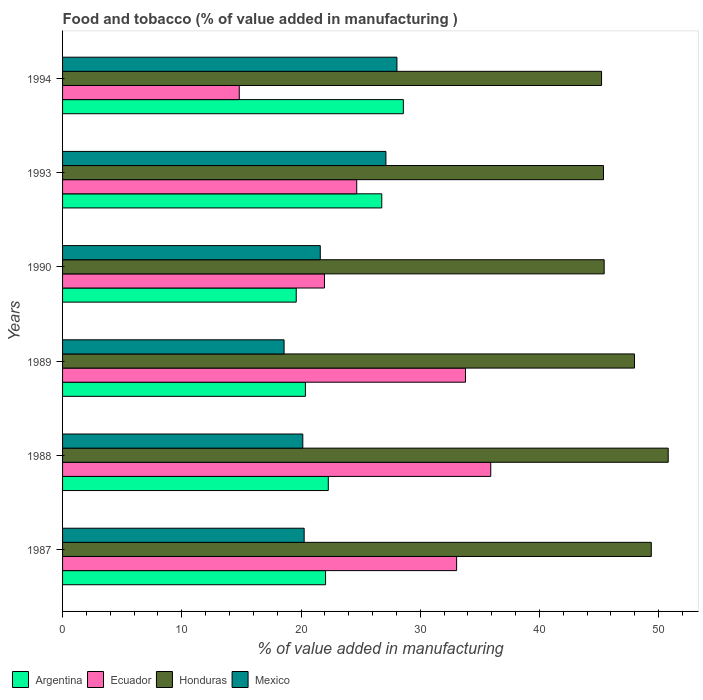How many different coloured bars are there?
Your response must be concise. 4. How many bars are there on the 6th tick from the top?
Make the answer very short. 4. How many bars are there on the 5th tick from the bottom?
Offer a very short reply. 4. What is the value added in manufacturing food and tobacco in Honduras in 1990?
Make the answer very short. 45.43. Across all years, what is the maximum value added in manufacturing food and tobacco in Mexico?
Provide a short and direct response. 28.05. Across all years, what is the minimum value added in manufacturing food and tobacco in Argentina?
Give a very brief answer. 19.6. What is the total value added in manufacturing food and tobacco in Mexico in the graph?
Offer a terse response. 135.79. What is the difference between the value added in manufacturing food and tobacco in Ecuador in 1987 and that in 1989?
Your response must be concise. -0.74. What is the difference between the value added in manufacturing food and tobacco in Honduras in 1990 and the value added in manufacturing food and tobacco in Ecuador in 1987?
Your answer should be compact. 12.38. What is the average value added in manufacturing food and tobacco in Honduras per year?
Provide a succinct answer. 47.36. In the year 1990, what is the difference between the value added in manufacturing food and tobacco in Argentina and value added in manufacturing food and tobacco in Honduras?
Offer a very short reply. -25.83. What is the ratio of the value added in manufacturing food and tobacco in Honduras in 1993 to that in 1994?
Keep it short and to the point. 1. Is the value added in manufacturing food and tobacco in Ecuador in 1987 less than that in 1994?
Provide a short and direct response. No. What is the difference between the highest and the second highest value added in manufacturing food and tobacco in Mexico?
Provide a short and direct response. 0.92. What is the difference between the highest and the lowest value added in manufacturing food and tobacco in Honduras?
Keep it short and to the point. 5.59. In how many years, is the value added in manufacturing food and tobacco in Ecuador greater than the average value added in manufacturing food and tobacco in Ecuador taken over all years?
Your answer should be very brief. 3. Is the sum of the value added in manufacturing food and tobacco in Ecuador in 1987 and 1994 greater than the maximum value added in manufacturing food and tobacco in Argentina across all years?
Make the answer very short. Yes. What does the 4th bar from the bottom in 1993 represents?
Ensure brevity in your answer.  Mexico. Is it the case that in every year, the sum of the value added in manufacturing food and tobacco in Honduras and value added in manufacturing food and tobacco in Ecuador is greater than the value added in manufacturing food and tobacco in Argentina?
Provide a succinct answer. Yes. Are all the bars in the graph horizontal?
Keep it short and to the point. Yes. How many years are there in the graph?
Make the answer very short. 6. Are the values on the major ticks of X-axis written in scientific E-notation?
Offer a very short reply. No. Does the graph contain any zero values?
Your answer should be compact. No. Does the graph contain grids?
Your answer should be compact. No. Where does the legend appear in the graph?
Your answer should be compact. Bottom left. How many legend labels are there?
Keep it short and to the point. 4. How are the legend labels stacked?
Provide a succinct answer. Horizontal. What is the title of the graph?
Make the answer very short. Food and tobacco (% of value added in manufacturing ). What is the label or title of the X-axis?
Give a very brief answer. % of value added in manufacturing. What is the % of value added in manufacturing in Argentina in 1987?
Offer a terse response. 22.06. What is the % of value added in manufacturing in Ecuador in 1987?
Provide a short and direct response. 33.05. What is the % of value added in manufacturing of Honduras in 1987?
Offer a terse response. 49.38. What is the % of value added in manufacturing in Mexico in 1987?
Make the answer very short. 20.26. What is the % of value added in manufacturing in Argentina in 1988?
Your answer should be very brief. 22.29. What is the % of value added in manufacturing of Ecuador in 1988?
Your answer should be compact. 35.92. What is the % of value added in manufacturing in Honduras in 1988?
Your answer should be compact. 50.8. What is the % of value added in manufacturing of Mexico in 1988?
Keep it short and to the point. 20.15. What is the % of value added in manufacturing of Argentina in 1989?
Your answer should be very brief. 20.37. What is the % of value added in manufacturing of Ecuador in 1989?
Your answer should be very brief. 33.8. What is the % of value added in manufacturing in Honduras in 1989?
Make the answer very short. 47.97. What is the % of value added in manufacturing of Mexico in 1989?
Provide a succinct answer. 18.58. What is the % of value added in manufacturing in Argentina in 1990?
Ensure brevity in your answer.  19.6. What is the % of value added in manufacturing of Ecuador in 1990?
Your answer should be very brief. 21.97. What is the % of value added in manufacturing in Honduras in 1990?
Keep it short and to the point. 45.43. What is the % of value added in manufacturing of Mexico in 1990?
Your answer should be compact. 21.62. What is the % of value added in manufacturing in Argentina in 1993?
Make the answer very short. 26.77. What is the % of value added in manufacturing of Ecuador in 1993?
Your answer should be compact. 24.68. What is the % of value added in manufacturing of Honduras in 1993?
Your answer should be very brief. 45.37. What is the % of value added in manufacturing of Mexico in 1993?
Offer a terse response. 27.12. What is the % of value added in manufacturing of Argentina in 1994?
Make the answer very short. 28.58. What is the % of value added in manufacturing of Ecuador in 1994?
Make the answer very short. 14.82. What is the % of value added in manufacturing of Honduras in 1994?
Your answer should be compact. 45.21. What is the % of value added in manufacturing in Mexico in 1994?
Keep it short and to the point. 28.05. Across all years, what is the maximum % of value added in manufacturing of Argentina?
Give a very brief answer. 28.58. Across all years, what is the maximum % of value added in manufacturing in Ecuador?
Give a very brief answer. 35.92. Across all years, what is the maximum % of value added in manufacturing of Honduras?
Your answer should be compact. 50.8. Across all years, what is the maximum % of value added in manufacturing of Mexico?
Offer a very short reply. 28.05. Across all years, what is the minimum % of value added in manufacturing of Argentina?
Your response must be concise. 19.6. Across all years, what is the minimum % of value added in manufacturing in Ecuador?
Offer a terse response. 14.82. Across all years, what is the minimum % of value added in manufacturing of Honduras?
Your response must be concise. 45.21. Across all years, what is the minimum % of value added in manufacturing of Mexico?
Ensure brevity in your answer.  18.58. What is the total % of value added in manufacturing in Argentina in the graph?
Your response must be concise. 139.68. What is the total % of value added in manufacturing in Ecuador in the graph?
Your answer should be very brief. 164.23. What is the total % of value added in manufacturing in Honduras in the graph?
Your answer should be compact. 284.17. What is the total % of value added in manufacturing of Mexico in the graph?
Your response must be concise. 135.79. What is the difference between the % of value added in manufacturing in Argentina in 1987 and that in 1988?
Your answer should be very brief. -0.23. What is the difference between the % of value added in manufacturing in Ecuador in 1987 and that in 1988?
Your response must be concise. -2.86. What is the difference between the % of value added in manufacturing in Honduras in 1987 and that in 1988?
Make the answer very short. -1.42. What is the difference between the % of value added in manufacturing of Mexico in 1987 and that in 1988?
Your response must be concise. 0.11. What is the difference between the % of value added in manufacturing of Argentina in 1987 and that in 1989?
Your answer should be compact. 1.69. What is the difference between the % of value added in manufacturing in Ecuador in 1987 and that in 1989?
Your response must be concise. -0.74. What is the difference between the % of value added in manufacturing in Honduras in 1987 and that in 1989?
Keep it short and to the point. 1.41. What is the difference between the % of value added in manufacturing in Mexico in 1987 and that in 1989?
Keep it short and to the point. 1.68. What is the difference between the % of value added in manufacturing in Argentina in 1987 and that in 1990?
Make the answer very short. 2.46. What is the difference between the % of value added in manufacturing in Ecuador in 1987 and that in 1990?
Your response must be concise. 11.08. What is the difference between the % of value added in manufacturing of Honduras in 1987 and that in 1990?
Make the answer very short. 3.95. What is the difference between the % of value added in manufacturing of Mexico in 1987 and that in 1990?
Provide a succinct answer. -1.35. What is the difference between the % of value added in manufacturing of Argentina in 1987 and that in 1993?
Provide a short and direct response. -4.71. What is the difference between the % of value added in manufacturing in Ecuador in 1987 and that in 1993?
Give a very brief answer. 8.38. What is the difference between the % of value added in manufacturing of Honduras in 1987 and that in 1993?
Your response must be concise. 4.01. What is the difference between the % of value added in manufacturing of Mexico in 1987 and that in 1993?
Your answer should be very brief. -6.86. What is the difference between the % of value added in manufacturing of Argentina in 1987 and that in 1994?
Offer a very short reply. -6.53. What is the difference between the % of value added in manufacturing of Ecuador in 1987 and that in 1994?
Offer a very short reply. 18.23. What is the difference between the % of value added in manufacturing in Honduras in 1987 and that in 1994?
Offer a terse response. 4.17. What is the difference between the % of value added in manufacturing in Mexico in 1987 and that in 1994?
Your answer should be compact. -7.78. What is the difference between the % of value added in manufacturing in Argentina in 1988 and that in 1989?
Make the answer very short. 1.92. What is the difference between the % of value added in manufacturing in Ecuador in 1988 and that in 1989?
Your answer should be very brief. 2.12. What is the difference between the % of value added in manufacturing of Honduras in 1988 and that in 1989?
Give a very brief answer. 2.83. What is the difference between the % of value added in manufacturing of Mexico in 1988 and that in 1989?
Offer a terse response. 1.57. What is the difference between the % of value added in manufacturing in Argentina in 1988 and that in 1990?
Make the answer very short. 2.69. What is the difference between the % of value added in manufacturing of Ecuador in 1988 and that in 1990?
Your answer should be compact. 13.95. What is the difference between the % of value added in manufacturing in Honduras in 1988 and that in 1990?
Keep it short and to the point. 5.37. What is the difference between the % of value added in manufacturing in Mexico in 1988 and that in 1990?
Offer a very short reply. -1.47. What is the difference between the % of value added in manufacturing in Argentina in 1988 and that in 1993?
Ensure brevity in your answer.  -4.48. What is the difference between the % of value added in manufacturing of Ecuador in 1988 and that in 1993?
Your response must be concise. 11.24. What is the difference between the % of value added in manufacturing of Honduras in 1988 and that in 1993?
Keep it short and to the point. 5.43. What is the difference between the % of value added in manufacturing of Mexico in 1988 and that in 1993?
Offer a terse response. -6.97. What is the difference between the % of value added in manufacturing of Argentina in 1988 and that in 1994?
Ensure brevity in your answer.  -6.29. What is the difference between the % of value added in manufacturing in Ecuador in 1988 and that in 1994?
Your answer should be compact. 21.1. What is the difference between the % of value added in manufacturing in Honduras in 1988 and that in 1994?
Your response must be concise. 5.59. What is the difference between the % of value added in manufacturing of Mexico in 1988 and that in 1994?
Give a very brief answer. -7.9. What is the difference between the % of value added in manufacturing in Argentina in 1989 and that in 1990?
Your answer should be very brief. 0.77. What is the difference between the % of value added in manufacturing in Ecuador in 1989 and that in 1990?
Ensure brevity in your answer.  11.83. What is the difference between the % of value added in manufacturing in Honduras in 1989 and that in 1990?
Your response must be concise. 2.54. What is the difference between the % of value added in manufacturing of Mexico in 1989 and that in 1990?
Offer a very short reply. -3.04. What is the difference between the % of value added in manufacturing of Argentina in 1989 and that in 1993?
Your answer should be compact. -6.4. What is the difference between the % of value added in manufacturing of Ecuador in 1989 and that in 1993?
Offer a very short reply. 9.12. What is the difference between the % of value added in manufacturing of Honduras in 1989 and that in 1993?
Your answer should be compact. 2.6. What is the difference between the % of value added in manufacturing of Mexico in 1989 and that in 1993?
Provide a short and direct response. -8.54. What is the difference between the % of value added in manufacturing in Argentina in 1989 and that in 1994?
Make the answer very short. -8.21. What is the difference between the % of value added in manufacturing of Ecuador in 1989 and that in 1994?
Give a very brief answer. 18.98. What is the difference between the % of value added in manufacturing in Honduras in 1989 and that in 1994?
Provide a short and direct response. 2.76. What is the difference between the % of value added in manufacturing of Mexico in 1989 and that in 1994?
Make the answer very short. -9.47. What is the difference between the % of value added in manufacturing in Argentina in 1990 and that in 1993?
Your answer should be compact. -7.17. What is the difference between the % of value added in manufacturing of Ecuador in 1990 and that in 1993?
Provide a short and direct response. -2.71. What is the difference between the % of value added in manufacturing of Honduras in 1990 and that in 1993?
Make the answer very short. 0.06. What is the difference between the % of value added in manufacturing in Mexico in 1990 and that in 1993?
Your answer should be very brief. -5.51. What is the difference between the % of value added in manufacturing of Argentina in 1990 and that in 1994?
Offer a very short reply. -8.98. What is the difference between the % of value added in manufacturing of Ecuador in 1990 and that in 1994?
Your response must be concise. 7.15. What is the difference between the % of value added in manufacturing in Honduras in 1990 and that in 1994?
Ensure brevity in your answer.  0.22. What is the difference between the % of value added in manufacturing of Mexico in 1990 and that in 1994?
Your response must be concise. -6.43. What is the difference between the % of value added in manufacturing of Argentina in 1993 and that in 1994?
Offer a very short reply. -1.81. What is the difference between the % of value added in manufacturing in Ecuador in 1993 and that in 1994?
Offer a very short reply. 9.85. What is the difference between the % of value added in manufacturing in Honduras in 1993 and that in 1994?
Ensure brevity in your answer.  0.16. What is the difference between the % of value added in manufacturing of Mexico in 1993 and that in 1994?
Give a very brief answer. -0.92. What is the difference between the % of value added in manufacturing of Argentina in 1987 and the % of value added in manufacturing of Ecuador in 1988?
Give a very brief answer. -13.86. What is the difference between the % of value added in manufacturing of Argentina in 1987 and the % of value added in manufacturing of Honduras in 1988?
Keep it short and to the point. -28.74. What is the difference between the % of value added in manufacturing of Argentina in 1987 and the % of value added in manufacturing of Mexico in 1988?
Give a very brief answer. 1.91. What is the difference between the % of value added in manufacturing in Ecuador in 1987 and the % of value added in manufacturing in Honduras in 1988?
Your answer should be compact. -17.75. What is the difference between the % of value added in manufacturing of Ecuador in 1987 and the % of value added in manufacturing of Mexico in 1988?
Provide a succinct answer. 12.9. What is the difference between the % of value added in manufacturing in Honduras in 1987 and the % of value added in manufacturing in Mexico in 1988?
Your answer should be compact. 29.23. What is the difference between the % of value added in manufacturing of Argentina in 1987 and the % of value added in manufacturing of Ecuador in 1989?
Your response must be concise. -11.74. What is the difference between the % of value added in manufacturing in Argentina in 1987 and the % of value added in manufacturing in Honduras in 1989?
Offer a terse response. -25.91. What is the difference between the % of value added in manufacturing of Argentina in 1987 and the % of value added in manufacturing of Mexico in 1989?
Give a very brief answer. 3.48. What is the difference between the % of value added in manufacturing of Ecuador in 1987 and the % of value added in manufacturing of Honduras in 1989?
Keep it short and to the point. -14.92. What is the difference between the % of value added in manufacturing of Ecuador in 1987 and the % of value added in manufacturing of Mexico in 1989?
Provide a succinct answer. 14.47. What is the difference between the % of value added in manufacturing in Honduras in 1987 and the % of value added in manufacturing in Mexico in 1989?
Your answer should be compact. 30.8. What is the difference between the % of value added in manufacturing in Argentina in 1987 and the % of value added in manufacturing in Ecuador in 1990?
Give a very brief answer. 0.09. What is the difference between the % of value added in manufacturing in Argentina in 1987 and the % of value added in manufacturing in Honduras in 1990?
Provide a short and direct response. -23.37. What is the difference between the % of value added in manufacturing of Argentina in 1987 and the % of value added in manufacturing of Mexico in 1990?
Keep it short and to the point. 0.44. What is the difference between the % of value added in manufacturing in Ecuador in 1987 and the % of value added in manufacturing in Honduras in 1990?
Provide a short and direct response. -12.38. What is the difference between the % of value added in manufacturing in Ecuador in 1987 and the % of value added in manufacturing in Mexico in 1990?
Your answer should be very brief. 11.44. What is the difference between the % of value added in manufacturing of Honduras in 1987 and the % of value added in manufacturing of Mexico in 1990?
Offer a terse response. 27.77. What is the difference between the % of value added in manufacturing in Argentina in 1987 and the % of value added in manufacturing in Ecuador in 1993?
Your answer should be very brief. -2.62. What is the difference between the % of value added in manufacturing in Argentina in 1987 and the % of value added in manufacturing in Honduras in 1993?
Make the answer very short. -23.31. What is the difference between the % of value added in manufacturing of Argentina in 1987 and the % of value added in manufacturing of Mexico in 1993?
Give a very brief answer. -5.06. What is the difference between the % of value added in manufacturing in Ecuador in 1987 and the % of value added in manufacturing in Honduras in 1993?
Your response must be concise. -12.32. What is the difference between the % of value added in manufacturing in Ecuador in 1987 and the % of value added in manufacturing in Mexico in 1993?
Give a very brief answer. 5.93. What is the difference between the % of value added in manufacturing of Honduras in 1987 and the % of value added in manufacturing of Mexico in 1993?
Your response must be concise. 22.26. What is the difference between the % of value added in manufacturing in Argentina in 1987 and the % of value added in manufacturing in Ecuador in 1994?
Ensure brevity in your answer.  7.24. What is the difference between the % of value added in manufacturing of Argentina in 1987 and the % of value added in manufacturing of Honduras in 1994?
Ensure brevity in your answer.  -23.15. What is the difference between the % of value added in manufacturing of Argentina in 1987 and the % of value added in manufacturing of Mexico in 1994?
Offer a terse response. -5.99. What is the difference between the % of value added in manufacturing in Ecuador in 1987 and the % of value added in manufacturing in Honduras in 1994?
Ensure brevity in your answer.  -12.16. What is the difference between the % of value added in manufacturing of Ecuador in 1987 and the % of value added in manufacturing of Mexico in 1994?
Make the answer very short. 5.01. What is the difference between the % of value added in manufacturing in Honduras in 1987 and the % of value added in manufacturing in Mexico in 1994?
Your answer should be compact. 21.34. What is the difference between the % of value added in manufacturing in Argentina in 1988 and the % of value added in manufacturing in Ecuador in 1989?
Your answer should be very brief. -11.51. What is the difference between the % of value added in manufacturing of Argentina in 1988 and the % of value added in manufacturing of Honduras in 1989?
Give a very brief answer. -25.68. What is the difference between the % of value added in manufacturing of Argentina in 1988 and the % of value added in manufacturing of Mexico in 1989?
Ensure brevity in your answer.  3.71. What is the difference between the % of value added in manufacturing of Ecuador in 1988 and the % of value added in manufacturing of Honduras in 1989?
Provide a succinct answer. -12.05. What is the difference between the % of value added in manufacturing of Ecuador in 1988 and the % of value added in manufacturing of Mexico in 1989?
Keep it short and to the point. 17.34. What is the difference between the % of value added in manufacturing of Honduras in 1988 and the % of value added in manufacturing of Mexico in 1989?
Your answer should be very brief. 32.22. What is the difference between the % of value added in manufacturing in Argentina in 1988 and the % of value added in manufacturing in Ecuador in 1990?
Offer a very short reply. 0.32. What is the difference between the % of value added in manufacturing of Argentina in 1988 and the % of value added in manufacturing of Honduras in 1990?
Your response must be concise. -23.14. What is the difference between the % of value added in manufacturing in Argentina in 1988 and the % of value added in manufacturing in Mexico in 1990?
Offer a terse response. 0.67. What is the difference between the % of value added in manufacturing of Ecuador in 1988 and the % of value added in manufacturing of Honduras in 1990?
Your answer should be compact. -9.51. What is the difference between the % of value added in manufacturing of Ecuador in 1988 and the % of value added in manufacturing of Mexico in 1990?
Provide a short and direct response. 14.3. What is the difference between the % of value added in manufacturing of Honduras in 1988 and the % of value added in manufacturing of Mexico in 1990?
Provide a succinct answer. 29.18. What is the difference between the % of value added in manufacturing in Argentina in 1988 and the % of value added in manufacturing in Ecuador in 1993?
Your response must be concise. -2.39. What is the difference between the % of value added in manufacturing in Argentina in 1988 and the % of value added in manufacturing in Honduras in 1993?
Your response must be concise. -23.08. What is the difference between the % of value added in manufacturing in Argentina in 1988 and the % of value added in manufacturing in Mexico in 1993?
Offer a terse response. -4.83. What is the difference between the % of value added in manufacturing in Ecuador in 1988 and the % of value added in manufacturing in Honduras in 1993?
Provide a succinct answer. -9.46. What is the difference between the % of value added in manufacturing in Ecuador in 1988 and the % of value added in manufacturing in Mexico in 1993?
Your answer should be very brief. 8.79. What is the difference between the % of value added in manufacturing in Honduras in 1988 and the % of value added in manufacturing in Mexico in 1993?
Your response must be concise. 23.68. What is the difference between the % of value added in manufacturing of Argentina in 1988 and the % of value added in manufacturing of Ecuador in 1994?
Give a very brief answer. 7.47. What is the difference between the % of value added in manufacturing of Argentina in 1988 and the % of value added in manufacturing of Honduras in 1994?
Your answer should be compact. -22.92. What is the difference between the % of value added in manufacturing of Argentina in 1988 and the % of value added in manufacturing of Mexico in 1994?
Your response must be concise. -5.76. What is the difference between the % of value added in manufacturing of Ecuador in 1988 and the % of value added in manufacturing of Honduras in 1994?
Offer a very short reply. -9.29. What is the difference between the % of value added in manufacturing in Ecuador in 1988 and the % of value added in manufacturing in Mexico in 1994?
Offer a very short reply. 7.87. What is the difference between the % of value added in manufacturing in Honduras in 1988 and the % of value added in manufacturing in Mexico in 1994?
Make the answer very short. 22.75. What is the difference between the % of value added in manufacturing of Argentina in 1989 and the % of value added in manufacturing of Ecuador in 1990?
Make the answer very short. -1.6. What is the difference between the % of value added in manufacturing in Argentina in 1989 and the % of value added in manufacturing in Honduras in 1990?
Give a very brief answer. -25.06. What is the difference between the % of value added in manufacturing of Argentina in 1989 and the % of value added in manufacturing of Mexico in 1990?
Your answer should be very brief. -1.25. What is the difference between the % of value added in manufacturing in Ecuador in 1989 and the % of value added in manufacturing in Honduras in 1990?
Give a very brief answer. -11.63. What is the difference between the % of value added in manufacturing in Ecuador in 1989 and the % of value added in manufacturing in Mexico in 1990?
Offer a terse response. 12.18. What is the difference between the % of value added in manufacturing in Honduras in 1989 and the % of value added in manufacturing in Mexico in 1990?
Keep it short and to the point. 26.35. What is the difference between the % of value added in manufacturing of Argentina in 1989 and the % of value added in manufacturing of Ecuador in 1993?
Ensure brevity in your answer.  -4.31. What is the difference between the % of value added in manufacturing in Argentina in 1989 and the % of value added in manufacturing in Honduras in 1993?
Provide a succinct answer. -25. What is the difference between the % of value added in manufacturing of Argentina in 1989 and the % of value added in manufacturing of Mexico in 1993?
Offer a very short reply. -6.75. What is the difference between the % of value added in manufacturing in Ecuador in 1989 and the % of value added in manufacturing in Honduras in 1993?
Offer a very short reply. -11.58. What is the difference between the % of value added in manufacturing of Ecuador in 1989 and the % of value added in manufacturing of Mexico in 1993?
Offer a very short reply. 6.67. What is the difference between the % of value added in manufacturing of Honduras in 1989 and the % of value added in manufacturing of Mexico in 1993?
Offer a very short reply. 20.85. What is the difference between the % of value added in manufacturing in Argentina in 1989 and the % of value added in manufacturing in Ecuador in 1994?
Your response must be concise. 5.55. What is the difference between the % of value added in manufacturing of Argentina in 1989 and the % of value added in manufacturing of Honduras in 1994?
Keep it short and to the point. -24.84. What is the difference between the % of value added in manufacturing in Argentina in 1989 and the % of value added in manufacturing in Mexico in 1994?
Your answer should be compact. -7.68. What is the difference between the % of value added in manufacturing of Ecuador in 1989 and the % of value added in manufacturing of Honduras in 1994?
Your answer should be very brief. -11.41. What is the difference between the % of value added in manufacturing of Ecuador in 1989 and the % of value added in manufacturing of Mexico in 1994?
Your response must be concise. 5.75. What is the difference between the % of value added in manufacturing of Honduras in 1989 and the % of value added in manufacturing of Mexico in 1994?
Your response must be concise. 19.92. What is the difference between the % of value added in manufacturing in Argentina in 1990 and the % of value added in manufacturing in Ecuador in 1993?
Offer a terse response. -5.08. What is the difference between the % of value added in manufacturing in Argentina in 1990 and the % of value added in manufacturing in Honduras in 1993?
Your response must be concise. -25.77. What is the difference between the % of value added in manufacturing of Argentina in 1990 and the % of value added in manufacturing of Mexico in 1993?
Your response must be concise. -7.52. What is the difference between the % of value added in manufacturing in Ecuador in 1990 and the % of value added in manufacturing in Honduras in 1993?
Your response must be concise. -23.41. What is the difference between the % of value added in manufacturing in Ecuador in 1990 and the % of value added in manufacturing in Mexico in 1993?
Ensure brevity in your answer.  -5.16. What is the difference between the % of value added in manufacturing in Honduras in 1990 and the % of value added in manufacturing in Mexico in 1993?
Your response must be concise. 18.31. What is the difference between the % of value added in manufacturing of Argentina in 1990 and the % of value added in manufacturing of Ecuador in 1994?
Give a very brief answer. 4.78. What is the difference between the % of value added in manufacturing of Argentina in 1990 and the % of value added in manufacturing of Honduras in 1994?
Give a very brief answer. -25.61. What is the difference between the % of value added in manufacturing in Argentina in 1990 and the % of value added in manufacturing in Mexico in 1994?
Offer a terse response. -8.45. What is the difference between the % of value added in manufacturing in Ecuador in 1990 and the % of value added in manufacturing in Honduras in 1994?
Ensure brevity in your answer.  -23.24. What is the difference between the % of value added in manufacturing of Ecuador in 1990 and the % of value added in manufacturing of Mexico in 1994?
Give a very brief answer. -6.08. What is the difference between the % of value added in manufacturing of Honduras in 1990 and the % of value added in manufacturing of Mexico in 1994?
Give a very brief answer. 17.38. What is the difference between the % of value added in manufacturing in Argentina in 1993 and the % of value added in manufacturing in Ecuador in 1994?
Keep it short and to the point. 11.95. What is the difference between the % of value added in manufacturing in Argentina in 1993 and the % of value added in manufacturing in Honduras in 1994?
Your answer should be very brief. -18.44. What is the difference between the % of value added in manufacturing of Argentina in 1993 and the % of value added in manufacturing of Mexico in 1994?
Offer a terse response. -1.27. What is the difference between the % of value added in manufacturing in Ecuador in 1993 and the % of value added in manufacturing in Honduras in 1994?
Offer a terse response. -20.54. What is the difference between the % of value added in manufacturing of Ecuador in 1993 and the % of value added in manufacturing of Mexico in 1994?
Keep it short and to the point. -3.37. What is the difference between the % of value added in manufacturing of Honduras in 1993 and the % of value added in manufacturing of Mexico in 1994?
Give a very brief answer. 17.33. What is the average % of value added in manufacturing in Argentina per year?
Offer a very short reply. 23.28. What is the average % of value added in manufacturing in Ecuador per year?
Offer a terse response. 27.37. What is the average % of value added in manufacturing in Honduras per year?
Give a very brief answer. 47.36. What is the average % of value added in manufacturing in Mexico per year?
Your answer should be compact. 22.63. In the year 1987, what is the difference between the % of value added in manufacturing of Argentina and % of value added in manufacturing of Ecuador?
Your answer should be very brief. -10.99. In the year 1987, what is the difference between the % of value added in manufacturing in Argentina and % of value added in manufacturing in Honduras?
Your response must be concise. -27.32. In the year 1987, what is the difference between the % of value added in manufacturing in Argentina and % of value added in manufacturing in Mexico?
Your answer should be very brief. 1.8. In the year 1987, what is the difference between the % of value added in manufacturing in Ecuador and % of value added in manufacturing in Honduras?
Your answer should be compact. -16.33. In the year 1987, what is the difference between the % of value added in manufacturing in Ecuador and % of value added in manufacturing in Mexico?
Provide a succinct answer. 12.79. In the year 1987, what is the difference between the % of value added in manufacturing of Honduras and % of value added in manufacturing of Mexico?
Your answer should be compact. 29.12. In the year 1988, what is the difference between the % of value added in manufacturing in Argentina and % of value added in manufacturing in Ecuador?
Your response must be concise. -13.63. In the year 1988, what is the difference between the % of value added in manufacturing of Argentina and % of value added in manufacturing of Honduras?
Keep it short and to the point. -28.51. In the year 1988, what is the difference between the % of value added in manufacturing in Argentina and % of value added in manufacturing in Mexico?
Keep it short and to the point. 2.14. In the year 1988, what is the difference between the % of value added in manufacturing in Ecuador and % of value added in manufacturing in Honduras?
Offer a very short reply. -14.89. In the year 1988, what is the difference between the % of value added in manufacturing in Ecuador and % of value added in manufacturing in Mexico?
Keep it short and to the point. 15.77. In the year 1988, what is the difference between the % of value added in manufacturing in Honduras and % of value added in manufacturing in Mexico?
Your response must be concise. 30.65. In the year 1989, what is the difference between the % of value added in manufacturing in Argentina and % of value added in manufacturing in Ecuador?
Provide a succinct answer. -13.43. In the year 1989, what is the difference between the % of value added in manufacturing of Argentina and % of value added in manufacturing of Honduras?
Your response must be concise. -27.6. In the year 1989, what is the difference between the % of value added in manufacturing in Argentina and % of value added in manufacturing in Mexico?
Keep it short and to the point. 1.79. In the year 1989, what is the difference between the % of value added in manufacturing in Ecuador and % of value added in manufacturing in Honduras?
Give a very brief answer. -14.17. In the year 1989, what is the difference between the % of value added in manufacturing of Ecuador and % of value added in manufacturing of Mexico?
Give a very brief answer. 15.22. In the year 1989, what is the difference between the % of value added in manufacturing in Honduras and % of value added in manufacturing in Mexico?
Your answer should be very brief. 29.39. In the year 1990, what is the difference between the % of value added in manufacturing in Argentina and % of value added in manufacturing in Ecuador?
Your response must be concise. -2.37. In the year 1990, what is the difference between the % of value added in manufacturing of Argentina and % of value added in manufacturing of Honduras?
Your answer should be compact. -25.83. In the year 1990, what is the difference between the % of value added in manufacturing in Argentina and % of value added in manufacturing in Mexico?
Offer a very short reply. -2.02. In the year 1990, what is the difference between the % of value added in manufacturing of Ecuador and % of value added in manufacturing of Honduras?
Keep it short and to the point. -23.46. In the year 1990, what is the difference between the % of value added in manufacturing in Ecuador and % of value added in manufacturing in Mexico?
Your response must be concise. 0.35. In the year 1990, what is the difference between the % of value added in manufacturing of Honduras and % of value added in manufacturing of Mexico?
Offer a terse response. 23.81. In the year 1993, what is the difference between the % of value added in manufacturing in Argentina and % of value added in manufacturing in Ecuador?
Offer a very short reply. 2.1. In the year 1993, what is the difference between the % of value added in manufacturing of Argentina and % of value added in manufacturing of Honduras?
Keep it short and to the point. -18.6. In the year 1993, what is the difference between the % of value added in manufacturing of Argentina and % of value added in manufacturing of Mexico?
Provide a short and direct response. -0.35. In the year 1993, what is the difference between the % of value added in manufacturing of Ecuador and % of value added in manufacturing of Honduras?
Ensure brevity in your answer.  -20.7. In the year 1993, what is the difference between the % of value added in manufacturing of Ecuador and % of value added in manufacturing of Mexico?
Make the answer very short. -2.45. In the year 1993, what is the difference between the % of value added in manufacturing of Honduras and % of value added in manufacturing of Mexico?
Your answer should be very brief. 18.25. In the year 1994, what is the difference between the % of value added in manufacturing in Argentina and % of value added in manufacturing in Ecuador?
Ensure brevity in your answer.  13.76. In the year 1994, what is the difference between the % of value added in manufacturing of Argentina and % of value added in manufacturing of Honduras?
Give a very brief answer. -16.63. In the year 1994, what is the difference between the % of value added in manufacturing of Argentina and % of value added in manufacturing of Mexico?
Give a very brief answer. 0.54. In the year 1994, what is the difference between the % of value added in manufacturing in Ecuador and % of value added in manufacturing in Honduras?
Offer a very short reply. -30.39. In the year 1994, what is the difference between the % of value added in manufacturing in Ecuador and % of value added in manufacturing in Mexico?
Make the answer very short. -13.23. In the year 1994, what is the difference between the % of value added in manufacturing in Honduras and % of value added in manufacturing in Mexico?
Provide a succinct answer. 17.16. What is the ratio of the % of value added in manufacturing of Argentina in 1987 to that in 1988?
Offer a terse response. 0.99. What is the ratio of the % of value added in manufacturing in Ecuador in 1987 to that in 1988?
Your answer should be compact. 0.92. What is the ratio of the % of value added in manufacturing of Honduras in 1987 to that in 1988?
Offer a terse response. 0.97. What is the ratio of the % of value added in manufacturing of Mexico in 1987 to that in 1988?
Provide a short and direct response. 1.01. What is the ratio of the % of value added in manufacturing of Argentina in 1987 to that in 1989?
Ensure brevity in your answer.  1.08. What is the ratio of the % of value added in manufacturing of Honduras in 1987 to that in 1989?
Ensure brevity in your answer.  1.03. What is the ratio of the % of value added in manufacturing of Mexico in 1987 to that in 1989?
Make the answer very short. 1.09. What is the ratio of the % of value added in manufacturing of Argentina in 1987 to that in 1990?
Offer a terse response. 1.13. What is the ratio of the % of value added in manufacturing of Ecuador in 1987 to that in 1990?
Provide a succinct answer. 1.5. What is the ratio of the % of value added in manufacturing in Honduras in 1987 to that in 1990?
Your response must be concise. 1.09. What is the ratio of the % of value added in manufacturing of Mexico in 1987 to that in 1990?
Provide a succinct answer. 0.94. What is the ratio of the % of value added in manufacturing of Argentina in 1987 to that in 1993?
Your answer should be compact. 0.82. What is the ratio of the % of value added in manufacturing of Ecuador in 1987 to that in 1993?
Offer a terse response. 1.34. What is the ratio of the % of value added in manufacturing in Honduras in 1987 to that in 1993?
Offer a very short reply. 1.09. What is the ratio of the % of value added in manufacturing of Mexico in 1987 to that in 1993?
Offer a terse response. 0.75. What is the ratio of the % of value added in manufacturing in Argentina in 1987 to that in 1994?
Provide a short and direct response. 0.77. What is the ratio of the % of value added in manufacturing of Ecuador in 1987 to that in 1994?
Offer a very short reply. 2.23. What is the ratio of the % of value added in manufacturing of Honduras in 1987 to that in 1994?
Your answer should be very brief. 1.09. What is the ratio of the % of value added in manufacturing in Mexico in 1987 to that in 1994?
Your answer should be very brief. 0.72. What is the ratio of the % of value added in manufacturing in Argentina in 1988 to that in 1989?
Make the answer very short. 1.09. What is the ratio of the % of value added in manufacturing of Ecuador in 1988 to that in 1989?
Give a very brief answer. 1.06. What is the ratio of the % of value added in manufacturing in Honduras in 1988 to that in 1989?
Your answer should be compact. 1.06. What is the ratio of the % of value added in manufacturing in Mexico in 1988 to that in 1989?
Your answer should be compact. 1.08. What is the ratio of the % of value added in manufacturing of Argentina in 1988 to that in 1990?
Offer a very short reply. 1.14. What is the ratio of the % of value added in manufacturing in Ecuador in 1988 to that in 1990?
Your answer should be compact. 1.63. What is the ratio of the % of value added in manufacturing of Honduras in 1988 to that in 1990?
Give a very brief answer. 1.12. What is the ratio of the % of value added in manufacturing of Mexico in 1988 to that in 1990?
Make the answer very short. 0.93. What is the ratio of the % of value added in manufacturing of Argentina in 1988 to that in 1993?
Give a very brief answer. 0.83. What is the ratio of the % of value added in manufacturing of Ecuador in 1988 to that in 1993?
Offer a very short reply. 1.46. What is the ratio of the % of value added in manufacturing of Honduras in 1988 to that in 1993?
Keep it short and to the point. 1.12. What is the ratio of the % of value added in manufacturing in Mexico in 1988 to that in 1993?
Give a very brief answer. 0.74. What is the ratio of the % of value added in manufacturing in Argentina in 1988 to that in 1994?
Your answer should be very brief. 0.78. What is the ratio of the % of value added in manufacturing of Ecuador in 1988 to that in 1994?
Keep it short and to the point. 2.42. What is the ratio of the % of value added in manufacturing in Honduras in 1988 to that in 1994?
Give a very brief answer. 1.12. What is the ratio of the % of value added in manufacturing in Mexico in 1988 to that in 1994?
Your answer should be very brief. 0.72. What is the ratio of the % of value added in manufacturing of Argentina in 1989 to that in 1990?
Keep it short and to the point. 1.04. What is the ratio of the % of value added in manufacturing of Ecuador in 1989 to that in 1990?
Keep it short and to the point. 1.54. What is the ratio of the % of value added in manufacturing of Honduras in 1989 to that in 1990?
Provide a short and direct response. 1.06. What is the ratio of the % of value added in manufacturing of Mexico in 1989 to that in 1990?
Your response must be concise. 0.86. What is the ratio of the % of value added in manufacturing in Argentina in 1989 to that in 1993?
Your response must be concise. 0.76. What is the ratio of the % of value added in manufacturing of Ecuador in 1989 to that in 1993?
Give a very brief answer. 1.37. What is the ratio of the % of value added in manufacturing of Honduras in 1989 to that in 1993?
Your answer should be very brief. 1.06. What is the ratio of the % of value added in manufacturing in Mexico in 1989 to that in 1993?
Provide a succinct answer. 0.69. What is the ratio of the % of value added in manufacturing of Argentina in 1989 to that in 1994?
Make the answer very short. 0.71. What is the ratio of the % of value added in manufacturing in Ecuador in 1989 to that in 1994?
Make the answer very short. 2.28. What is the ratio of the % of value added in manufacturing of Honduras in 1989 to that in 1994?
Your response must be concise. 1.06. What is the ratio of the % of value added in manufacturing in Mexico in 1989 to that in 1994?
Keep it short and to the point. 0.66. What is the ratio of the % of value added in manufacturing in Argentina in 1990 to that in 1993?
Keep it short and to the point. 0.73. What is the ratio of the % of value added in manufacturing in Ecuador in 1990 to that in 1993?
Your response must be concise. 0.89. What is the ratio of the % of value added in manufacturing of Mexico in 1990 to that in 1993?
Keep it short and to the point. 0.8. What is the ratio of the % of value added in manufacturing in Argentina in 1990 to that in 1994?
Provide a succinct answer. 0.69. What is the ratio of the % of value added in manufacturing in Ecuador in 1990 to that in 1994?
Offer a very short reply. 1.48. What is the ratio of the % of value added in manufacturing in Honduras in 1990 to that in 1994?
Provide a succinct answer. 1. What is the ratio of the % of value added in manufacturing in Mexico in 1990 to that in 1994?
Your answer should be compact. 0.77. What is the ratio of the % of value added in manufacturing in Argentina in 1993 to that in 1994?
Offer a very short reply. 0.94. What is the ratio of the % of value added in manufacturing of Ecuador in 1993 to that in 1994?
Keep it short and to the point. 1.66. What is the ratio of the % of value added in manufacturing in Honduras in 1993 to that in 1994?
Offer a terse response. 1. What is the ratio of the % of value added in manufacturing in Mexico in 1993 to that in 1994?
Keep it short and to the point. 0.97. What is the difference between the highest and the second highest % of value added in manufacturing of Argentina?
Provide a succinct answer. 1.81. What is the difference between the highest and the second highest % of value added in manufacturing of Ecuador?
Your answer should be very brief. 2.12. What is the difference between the highest and the second highest % of value added in manufacturing of Honduras?
Give a very brief answer. 1.42. What is the difference between the highest and the second highest % of value added in manufacturing in Mexico?
Your answer should be compact. 0.92. What is the difference between the highest and the lowest % of value added in manufacturing of Argentina?
Offer a terse response. 8.98. What is the difference between the highest and the lowest % of value added in manufacturing of Ecuador?
Your answer should be compact. 21.1. What is the difference between the highest and the lowest % of value added in manufacturing in Honduras?
Offer a terse response. 5.59. What is the difference between the highest and the lowest % of value added in manufacturing of Mexico?
Your answer should be compact. 9.47. 